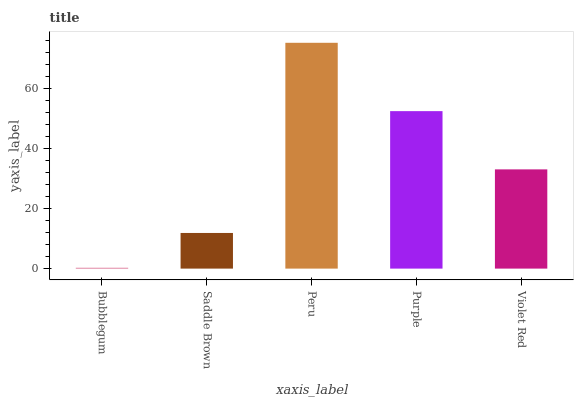Is Bubblegum the minimum?
Answer yes or no. Yes. Is Peru the maximum?
Answer yes or no. Yes. Is Saddle Brown the minimum?
Answer yes or no. No. Is Saddle Brown the maximum?
Answer yes or no. No. Is Saddle Brown greater than Bubblegum?
Answer yes or no. Yes. Is Bubblegum less than Saddle Brown?
Answer yes or no. Yes. Is Bubblegum greater than Saddle Brown?
Answer yes or no. No. Is Saddle Brown less than Bubblegum?
Answer yes or no. No. Is Violet Red the high median?
Answer yes or no. Yes. Is Violet Red the low median?
Answer yes or no. Yes. Is Saddle Brown the high median?
Answer yes or no. No. Is Peru the low median?
Answer yes or no. No. 